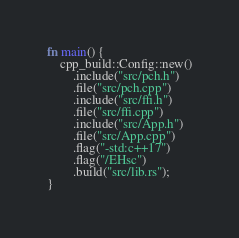Convert code to text. <code><loc_0><loc_0><loc_500><loc_500><_Rust_>fn main() {
    cpp_build::Config::new()
        .include("src/pch.h")
        .file("src/pch.cpp")
        .include("src/ffi.h")
        .file("src/ffi.cpp")
        .include("src/App.h")
        .file("src/App.cpp")
        .flag("-std:c++17")
        .flag("/EHsc")
        .build("src/lib.rs");
}
</code> 